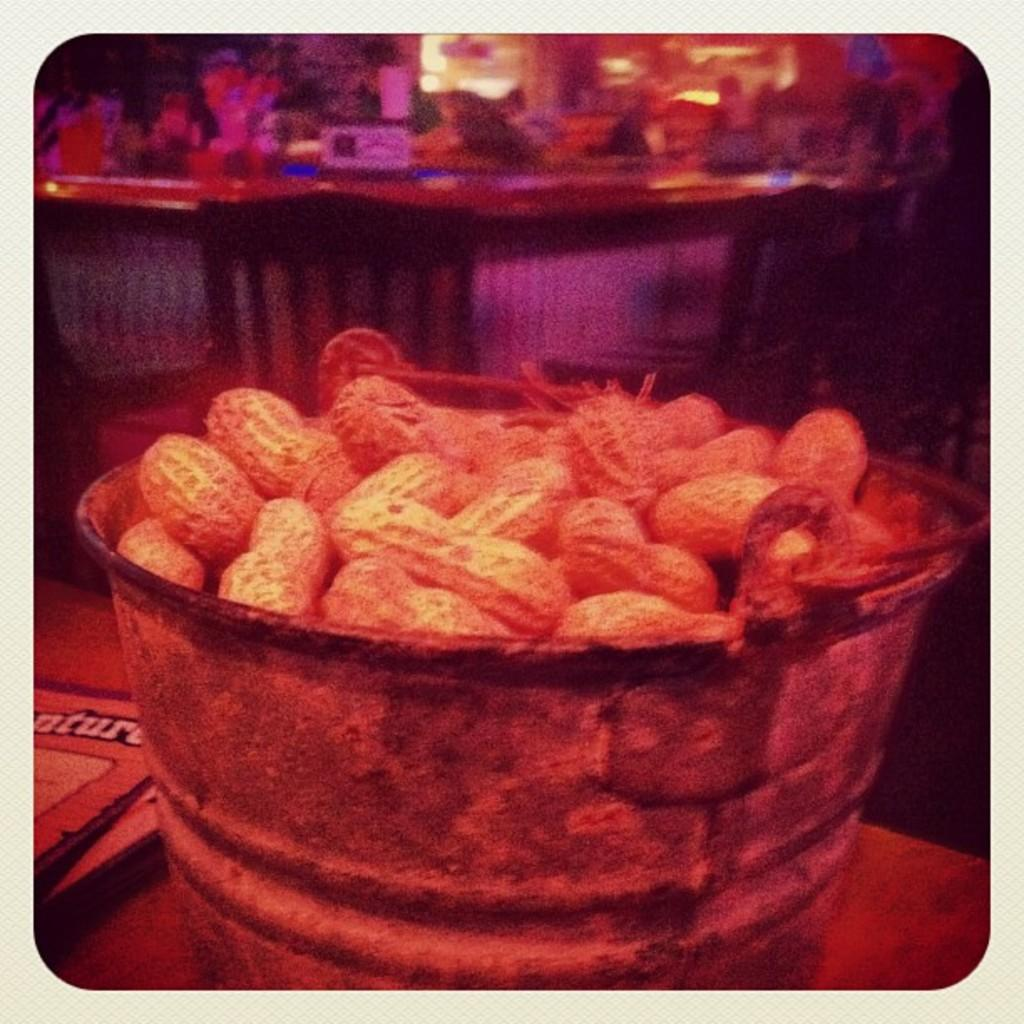What is the main object in the center of the image? There is a bucket in the center of the image. What is inside the bucket? The bucket contains groundnuts. Where is the bucket placed? The bucket is placed on a table. What else can be seen on the table in the image? There are objects on the table in the background. What type of furniture is visible in the background? There are chairs in the background. What type of cable is connected to the bucket in the image? There is no cable connected to the bucket in the image; it is simply a bucket containing groundnuts. What color is the pencil used to draw on the groundnuts in the image? There is no pencil or drawing on the groundnuts in the image; it is just a bucket of groundnuts on a table. 